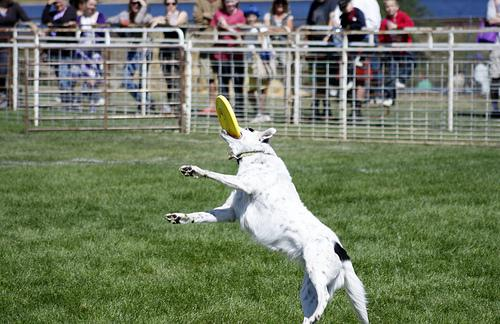Question: why is the dog on the field?
Choices:
A. Running.
B. Tracking.
C. Playing.
D. Racing.
Answer with the letter. Answer: C Question: what color is the frisbee?
Choices:
A. Pink.
B. Yellow.
C. Red.
D. Purple.
Answer with the letter. Answer: B Question: what is the ground made of?
Choices:
A. Grass.
B. Dirt.
C. Mud.
D. Minerals.
Answer with the letter. Answer: A Question: who is watching the dog?
Choices:
A. Group of people.
B. The boy.
C. The girl.
D. The owner.
Answer with the letter. Answer: A Question: when was the photo taken?
Choices:
A. At a night time event.
B. During the day.
C. During a family get together.
D. On a car trip to Hershey Park.
Answer with the letter. Answer: B 